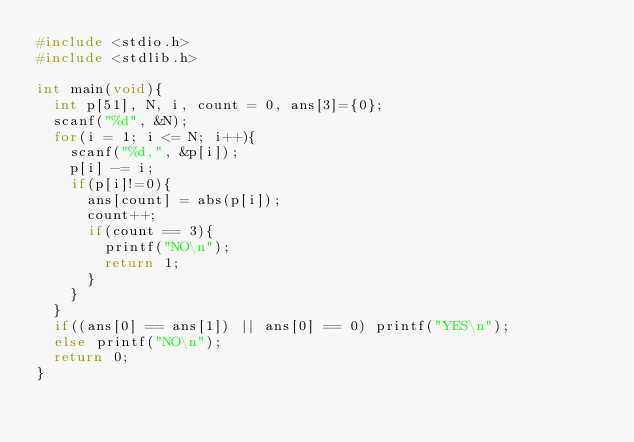Convert code to text. <code><loc_0><loc_0><loc_500><loc_500><_C_>#include <stdio.h>
#include <stdlib.h>

int main(void){
	int p[51], N, i, count = 0, ans[3]={0};
	scanf("%d", &N);
	for(i = 1; i <= N; i++){
		scanf("%d,", &p[i]);
		p[i] -= i;
		if(p[i]!=0){
			ans[count] = abs(p[i]);
			count++;
			if(count == 3){
				printf("NO\n");
				return 1;
			}
		}
	}
	if((ans[0] == ans[1]) || ans[0] == 0) printf("YES\n");
	else printf("NO\n");
	return 0;
}</code> 